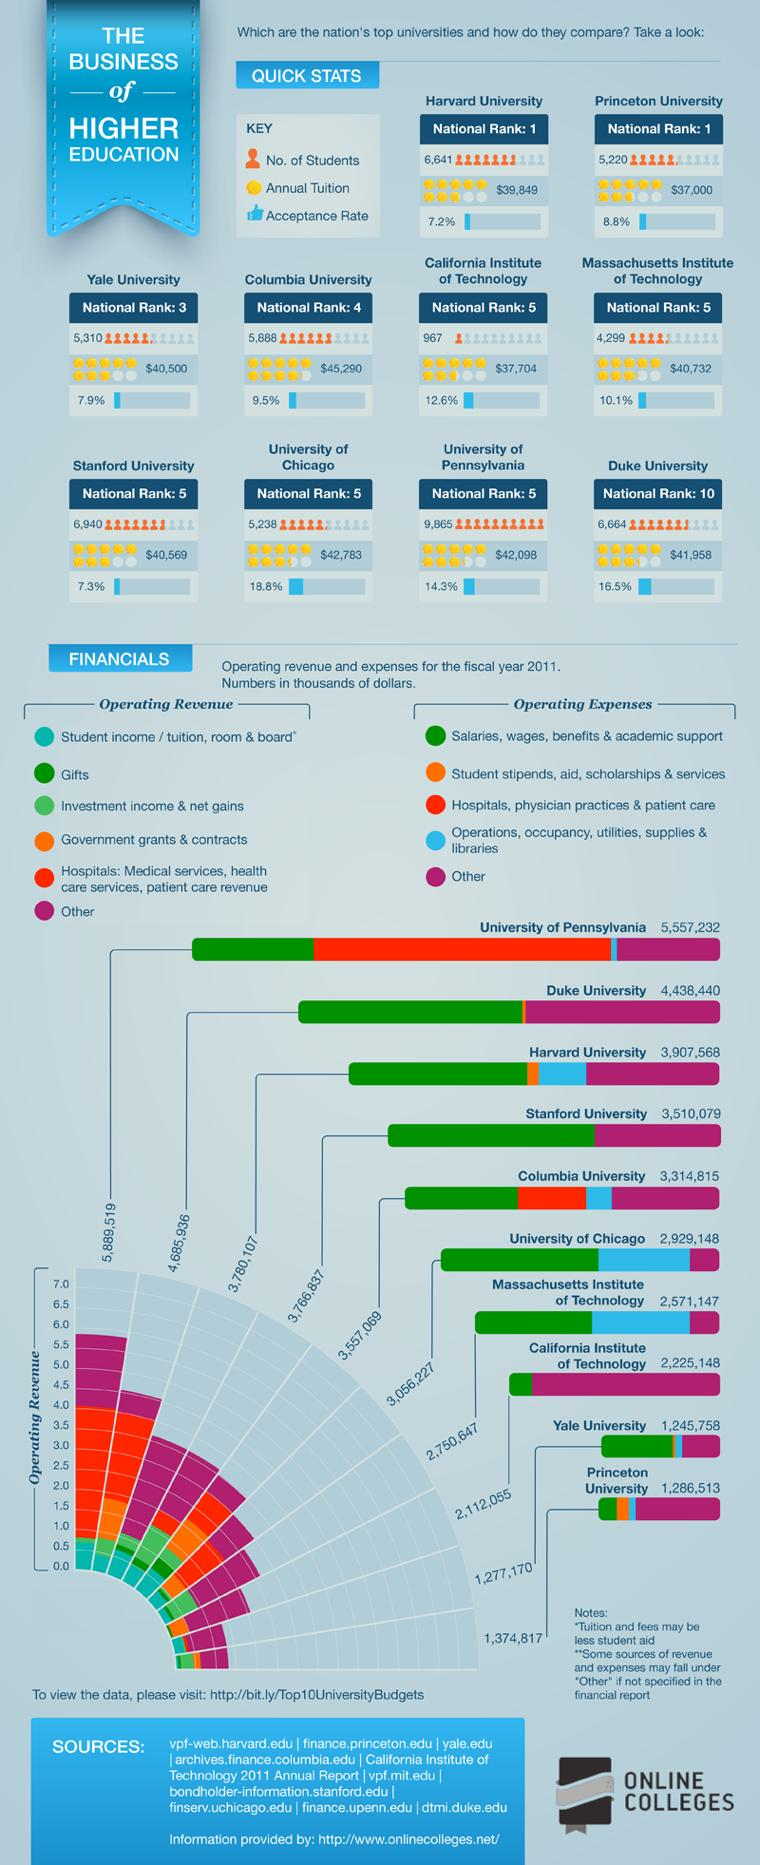Specify some key components in this picture. The info graphic contains 10 universities. The annual tuition fee at Harvard University is $39,849. It is estimated that approximately 5,310 students are currently enrolled at Yale University. Duke University is ranked as the 10th best national university in the United States. There are approximately 6,664 students currently studying at Duke University. 